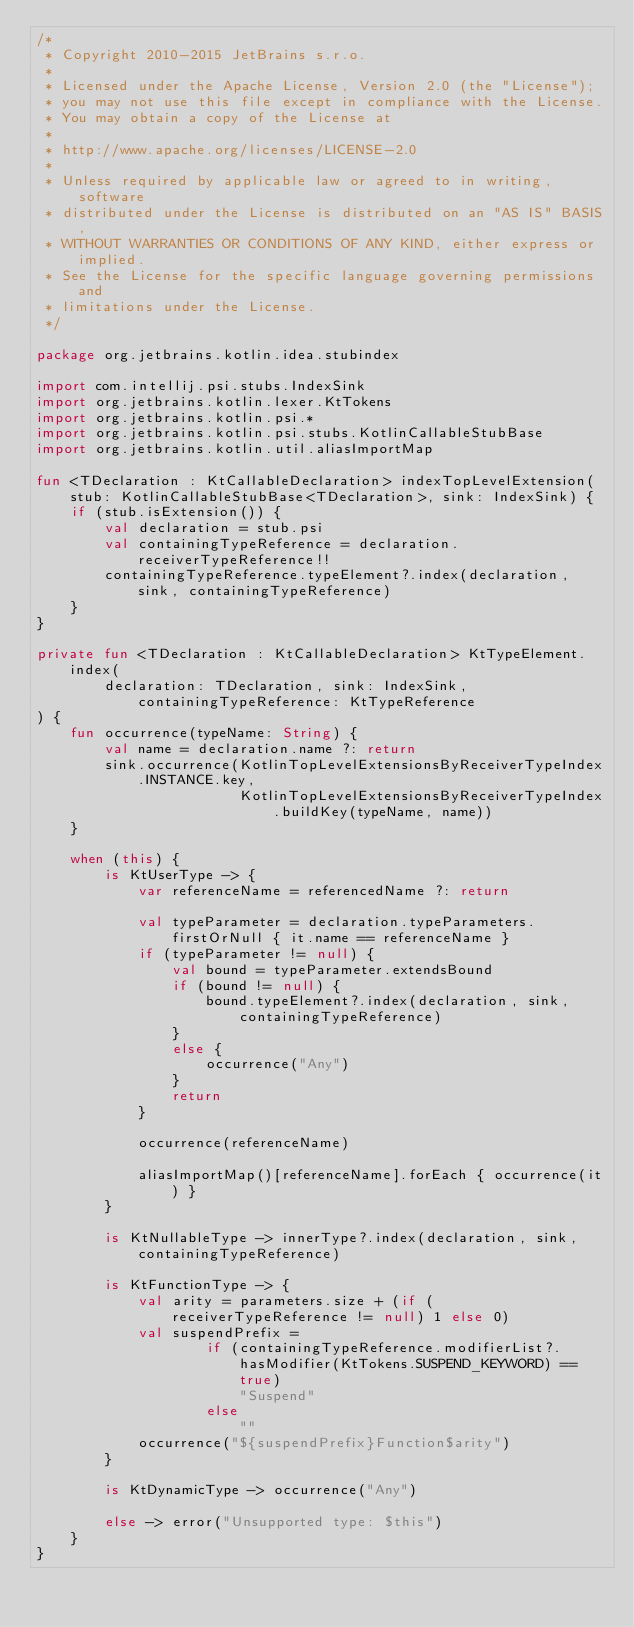Convert code to text. <code><loc_0><loc_0><loc_500><loc_500><_Kotlin_>/*
 * Copyright 2010-2015 JetBrains s.r.o.
 *
 * Licensed under the Apache License, Version 2.0 (the "License");
 * you may not use this file except in compliance with the License.
 * You may obtain a copy of the License at
 *
 * http://www.apache.org/licenses/LICENSE-2.0
 *
 * Unless required by applicable law or agreed to in writing, software
 * distributed under the License is distributed on an "AS IS" BASIS,
 * WITHOUT WARRANTIES OR CONDITIONS OF ANY KIND, either express or implied.
 * See the License for the specific language governing permissions and
 * limitations under the License.
 */

package org.jetbrains.kotlin.idea.stubindex

import com.intellij.psi.stubs.IndexSink
import org.jetbrains.kotlin.lexer.KtTokens
import org.jetbrains.kotlin.psi.*
import org.jetbrains.kotlin.psi.stubs.KotlinCallableStubBase
import org.jetbrains.kotlin.util.aliasImportMap

fun <TDeclaration : KtCallableDeclaration> indexTopLevelExtension(stub: KotlinCallableStubBase<TDeclaration>, sink: IndexSink) {
    if (stub.isExtension()) {
        val declaration = stub.psi
        val containingTypeReference = declaration.receiverTypeReference!!
        containingTypeReference.typeElement?.index(declaration, sink, containingTypeReference)
    }
}

private fun <TDeclaration : KtCallableDeclaration> KtTypeElement.index(
        declaration: TDeclaration, sink: IndexSink, containingTypeReference: KtTypeReference
) {
    fun occurrence(typeName: String) {
        val name = declaration.name ?: return
        sink.occurrence(KotlinTopLevelExtensionsByReceiverTypeIndex.INSTANCE.key,
                        KotlinTopLevelExtensionsByReceiverTypeIndex.buildKey(typeName, name))
    }

    when (this) {
        is KtUserType -> {
            var referenceName = referencedName ?: return

            val typeParameter = declaration.typeParameters.firstOrNull { it.name == referenceName }
            if (typeParameter != null) {
                val bound = typeParameter.extendsBound
                if (bound != null) {
                    bound.typeElement?.index(declaration, sink, containingTypeReference)
                }
                else {
                    occurrence("Any")
                }
                return
            }

            occurrence(referenceName)

            aliasImportMap()[referenceName].forEach { occurrence(it) }
        }

        is KtNullableType -> innerType?.index(declaration, sink, containingTypeReference)

        is KtFunctionType -> {
            val arity = parameters.size + (if (receiverTypeReference != null) 1 else 0)
            val suspendPrefix =
                    if (containingTypeReference.modifierList?.hasModifier(KtTokens.SUSPEND_KEYWORD) == true)
                        "Suspend"
                    else
                        ""
            occurrence("${suspendPrefix}Function$arity")
        }

        is KtDynamicType -> occurrence("Any")

        else -> error("Unsupported type: $this")
    }
}
</code> 